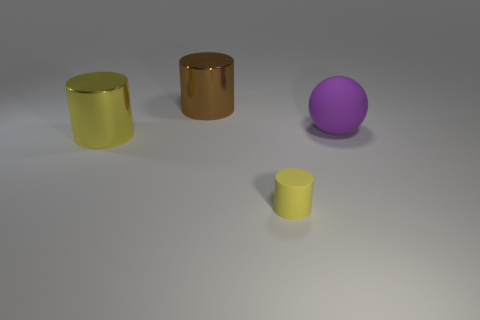How many objects are large brown blocks or cylinders that are in front of the large purple sphere?
Your answer should be very brief. 2. How many other things are the same material as the large yellow cylinder?
Provide a succinct answer. 1. What number of things are either balls or large yellow objects?
Your answer should be compact. 2. Are there more yellow cylinders that are behind the tiny object than big spheres on the left side of the big brown shiny cylinder?
Offer a very short reply. Yes. There is a big metal cylinder that is on the left side of the big brown cylinder; does it have the same color as the cylinder to the right of the brown cylinder?
Your answer should be compact. Yes. There is a cylinder in front of the large metallic thing in front of the big shiny thing that is behind the large yellow metallic object; how big is it?
Provide a succinct answer. Small. What color is the other small thing that is the same shape as the brown object?
Make the answer very short. Yellow. Are there more metal things behind the big yellow object than big red objects?
Offer a terse response. Yes. There is a brown thing; is its shape the same as the matte object that is in front of the yellow metal thing?
Your response must be concise. Yes. Is there anything else that is the same size as the rubber cylinder?
Make the answer very short. No. 